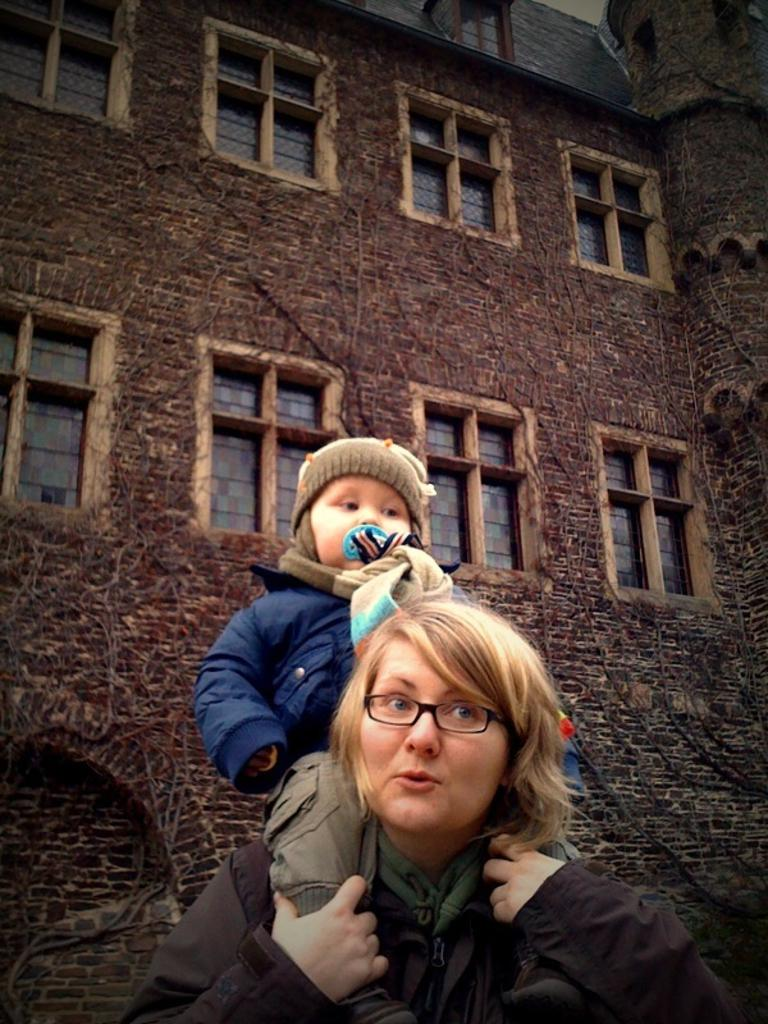What structure is present in the image? There is a building in the image. What architectural feature can be seen on the building? There are windows in the building. How many people are visible in the image? There are two people in the front of the image. What type of scarf is the building wearing in the image? The building is not wearing a scarf, as it is a structure and not a living being. What type of frame is holding the building in the image? The building is not held by a frame, as it is a freestanding structure. 